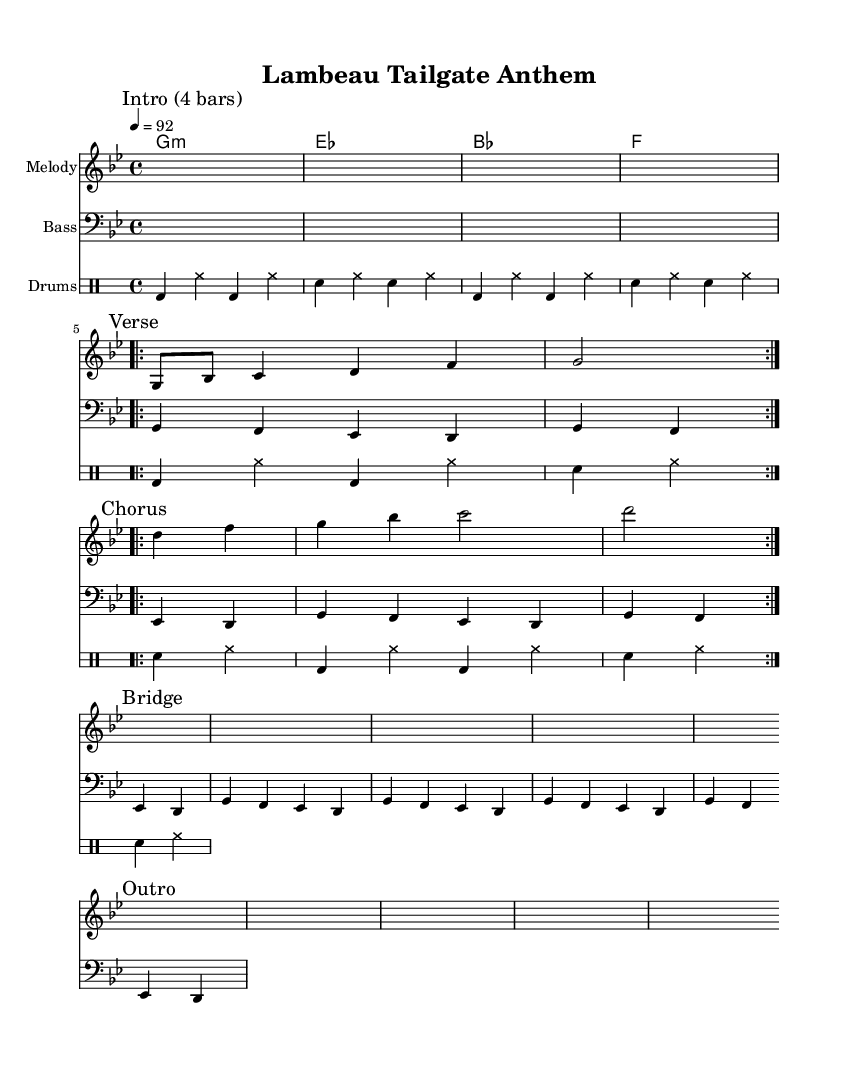What is the key signature of this music? The key signature is G minor, which indicates two flats (B♭ and E♭) in the scale.
Answer: G minor What is the time signature of this music? The time signature is 4/4, which means there are four beats in each measure and the quarter note receives one beat.
Answer: 4/4 What is the tempo marking in this music? The tempo marking is 92, meaning the piece should be played at 92 beats per minute.
Answer: 92 How many measures are in the verse section? The verse section is repeated two times, each containing four measures, resulting in a total of eight measures for the verse.
Answer: 8 What is the instrument marked for the drum section? The instrument marked for the drum section is "Drums," indicating that this staff is for percussion instruments.
Answer: Drums How many times is the chorus melody repeated? The chorus melody is repeated two times according to the markings in the sheet music.
Answer: 2 What type of music structure is this piece following? The overall structure follows a typical verse-chorus form, with defined sections for verses, a chorus, and an outro.
Answer: Verse-chorus 